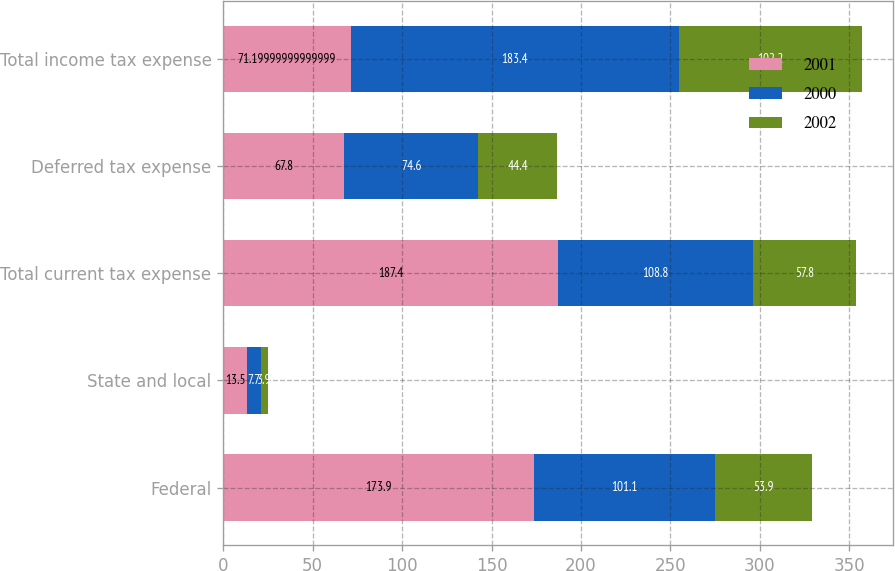<chart> <loc_0><loc_0><loc_500><loc_500><stacked_bar_chart><ecel><fcel>Federal<fcel>State and local<fcel>Total current tax expense<fcel>Deferred tax expense<fcel>Total income tax expense<nl><fcel>2001<fcel>173.9<fcel>13.5<fcel>187.4<fcel>67.8<fcel>71.2<nl><fcel>2000<fcel>101.1<fcel>7.7<fcel>108.8<fcel>74.6<fcel>183.4<nl><fcel>2002<fcel>53.9<fcel>3.9<fcel>57.8<fcel>44.4<fcel>102.2<nl></chart> 